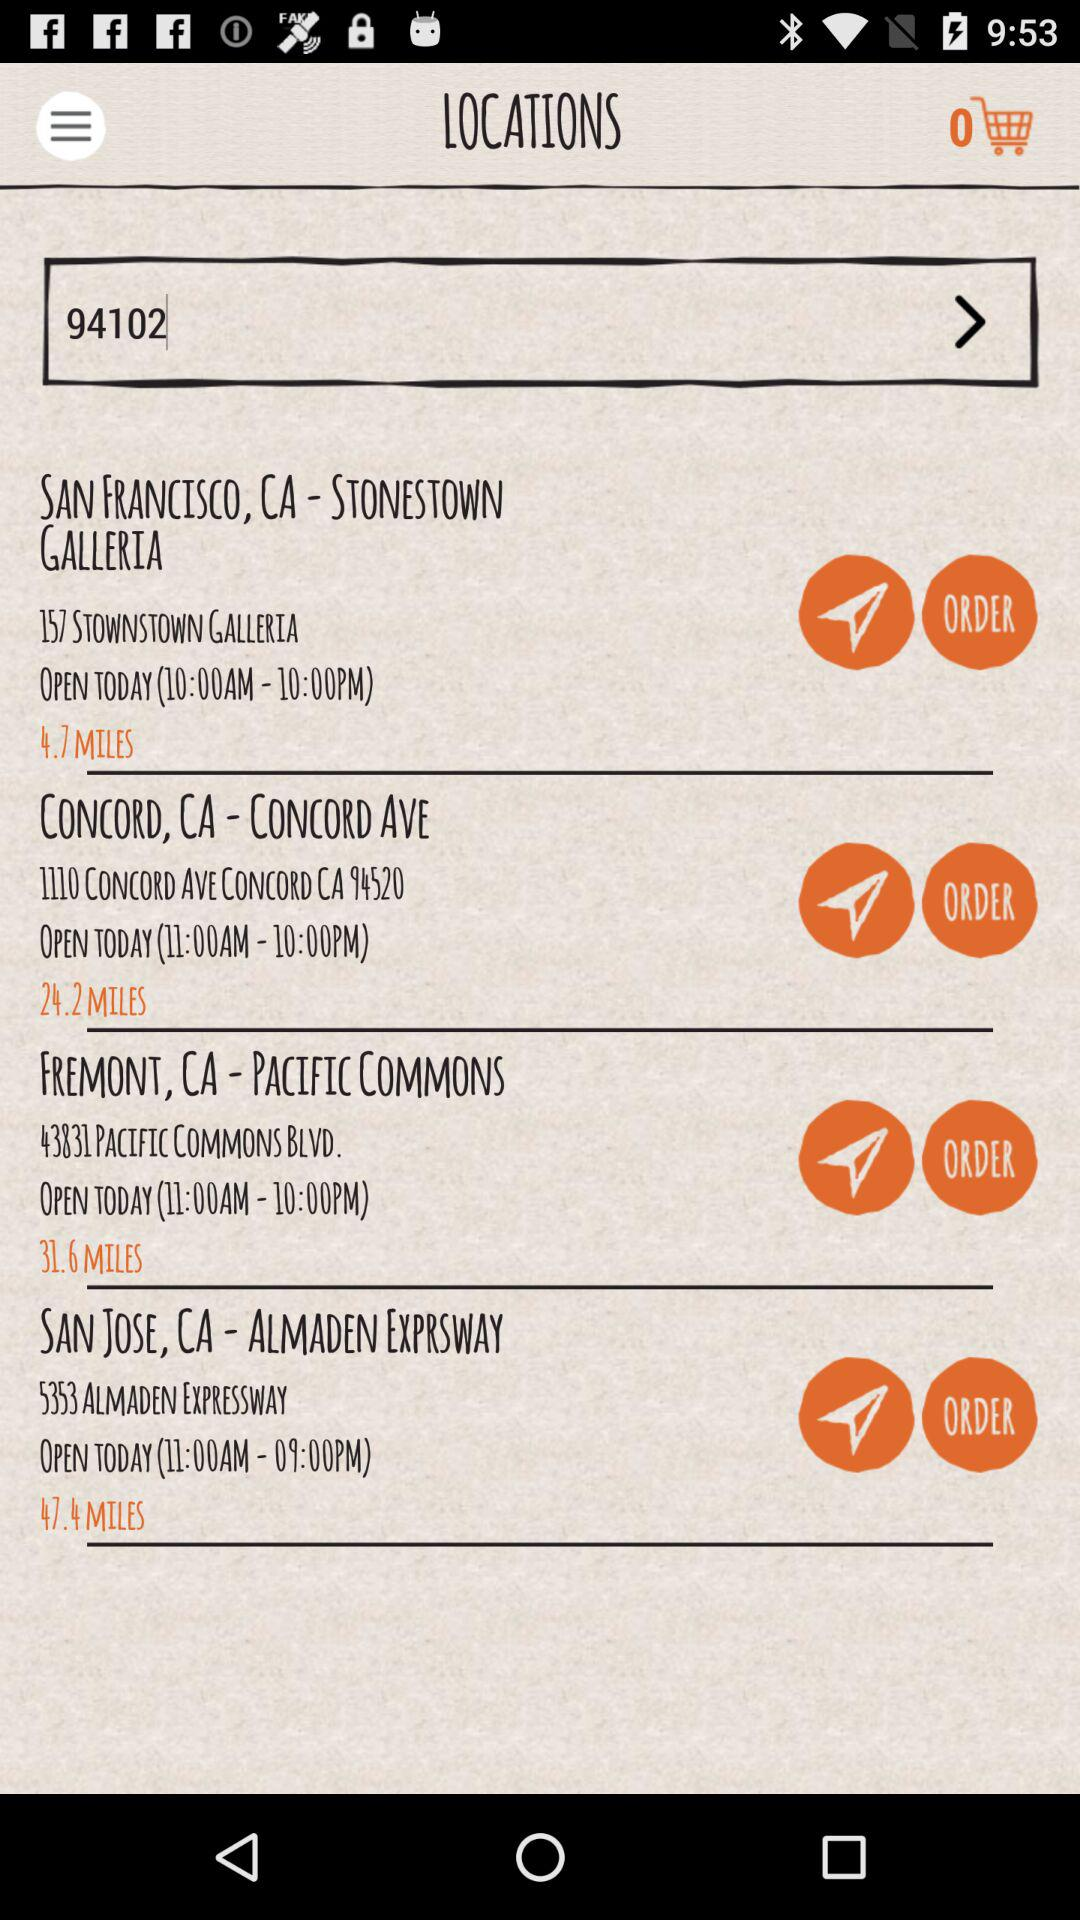What is the distance between "STONESTOWN GALLERIA" in San Francisco, CA and where I am? The distance is 4.7 miles. 